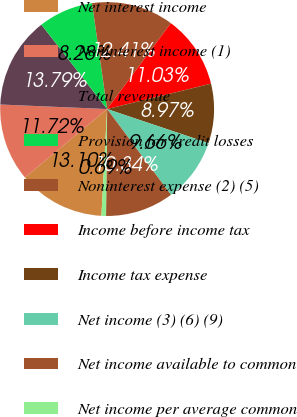Convert chart. <chart><loc_0><loc_0><loc_500><loc_500><pie_chart><fcel>Net interest income<fcel>Noninterest income (1)<fcel>Total revenue<fcel>Provision for credit losses<fcel>Noninterest expense (2) (5)<fcel>Income before income tax<fcel>Income tax expense<fcel>Net income (3) (6) (9)<fcel>Net income available to common<fcel>Net income per average common<nl><fcel>13.1%<fcel>11.72%<fcel>13.79%<fcel>8.28%<fcel>12.41%<fcel>11.03%<fcel>8.97%<fcel>9.66%<fcel>10.34%<fcel>0.69%<nl></chart> 